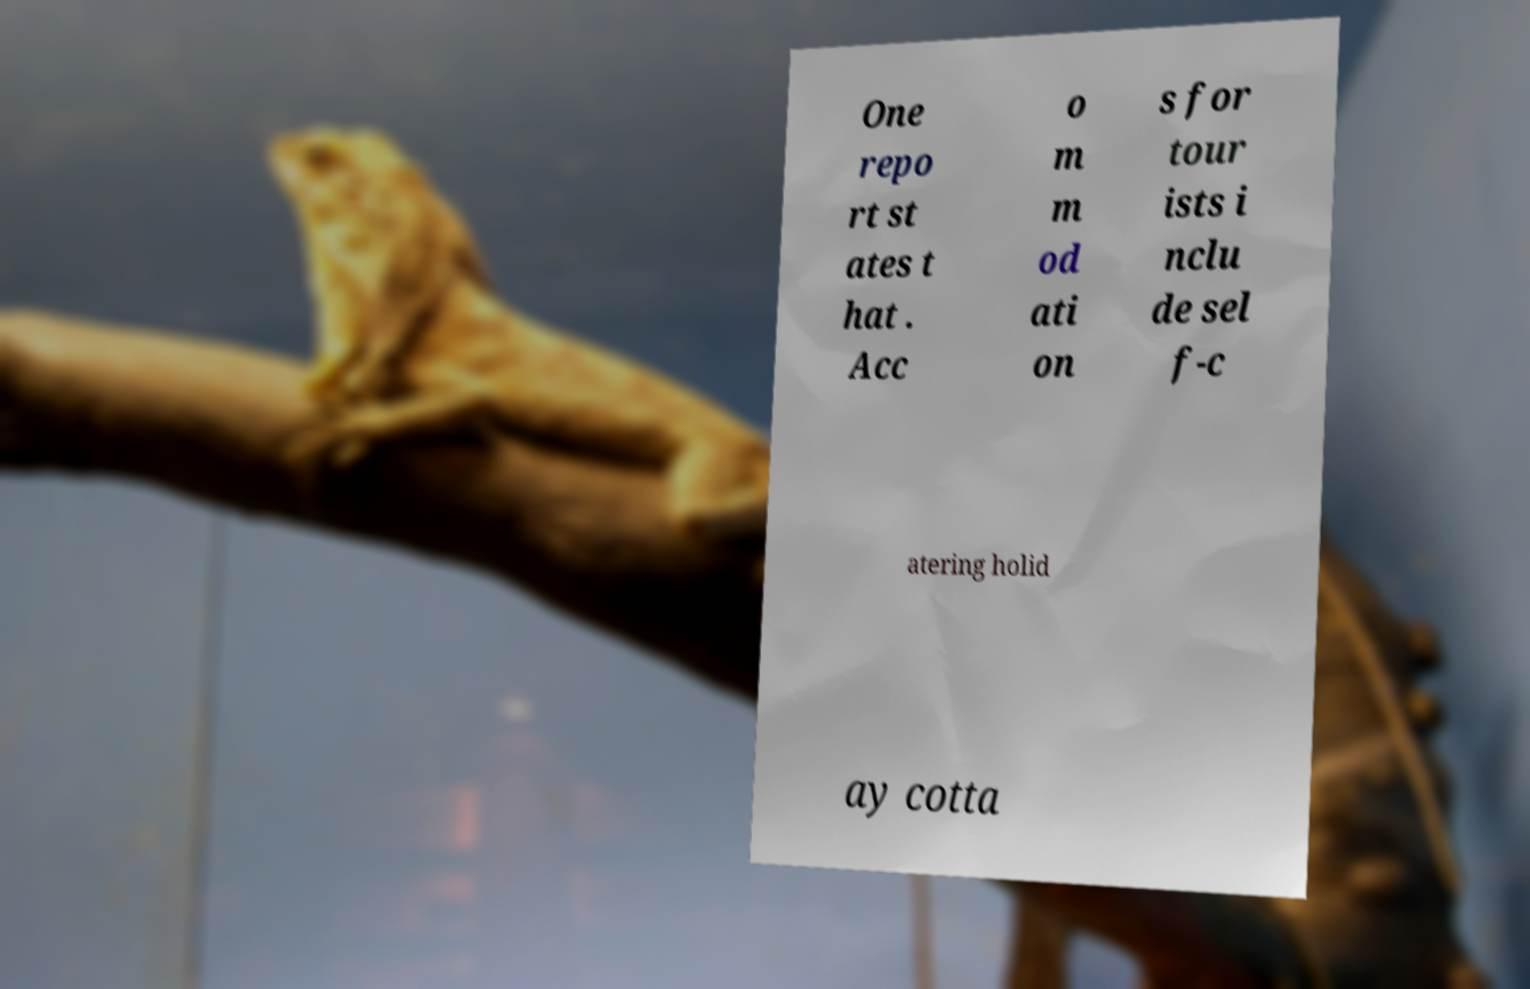Can you accurately transcribe the text from the provided image for me? One repo rt st ates t hat . Acc o m m od ati on s for tour ists i nclu de sel f-c atering holid ay cotta 